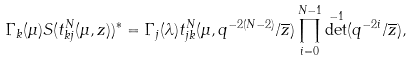<formula> <loc_0><loc_0><loc_500><loc_500>\Gamma _ { k } ( \mu ) S ( t _ { k j } ^ { N } ( \mu , z ) ) ^ { * } = \Gamma _ { j } ( \lambda ) t _ { j k } ^ { N } ( \mu , q ^ { - 2 ( N - 2 ) } / \overline { z } ) \prod _ { i = 0 } ^ { N - 1 } \det ^ { - 1 } ( q ^ { - 2 i } / \overline { z } ) ,</formula> 